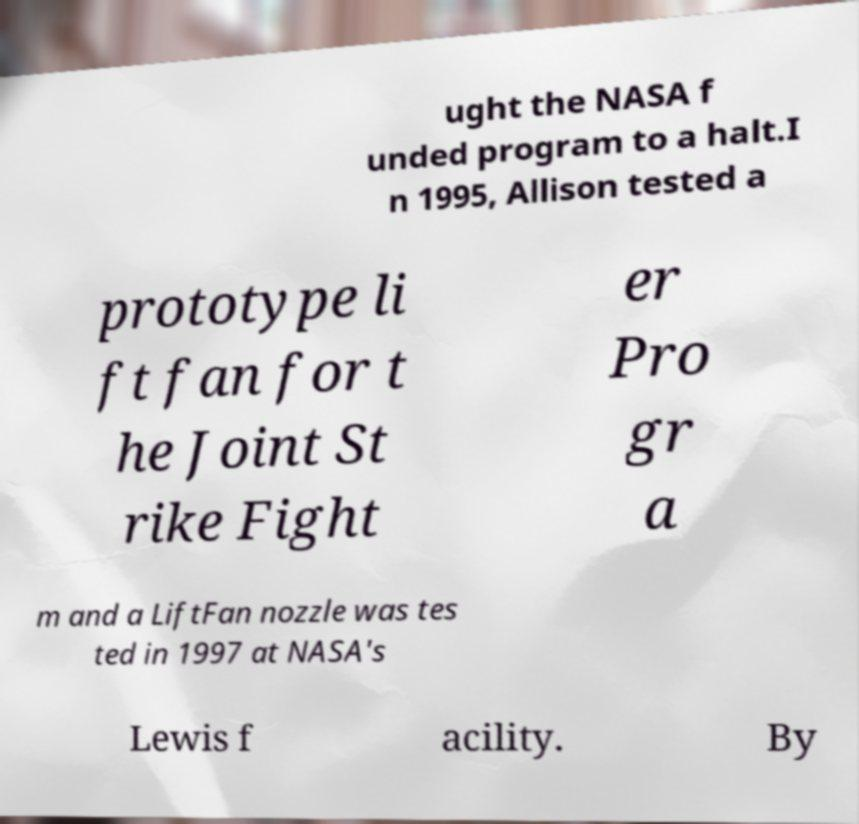Could you extract and type out the text from this image? ught the NASA f unded program to a halt.I n 1995, Allison tested a prototype li ft fan for t he Joint St rike Fight er Pro gr a m and a LiftFan nozzle was tes ted in 1997 at NASA's Lewis f acility. By 